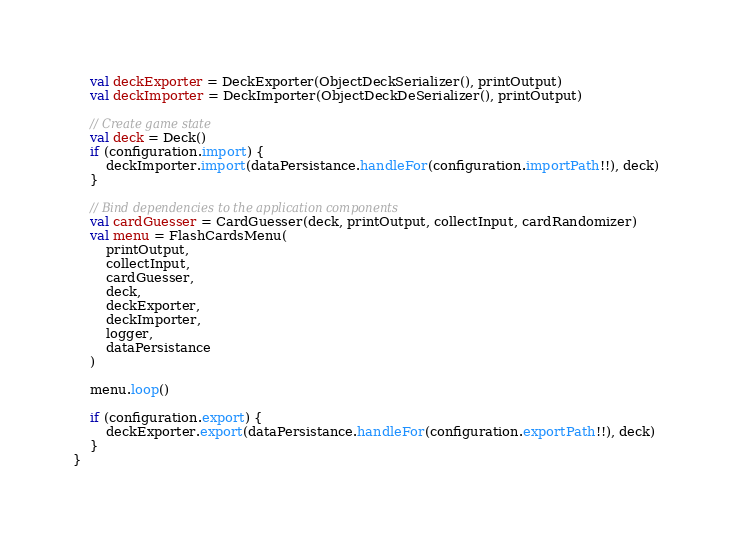Convert code to text. <code><loc_0><loc_0><loc_500><loc_500><_Kotlin_>    val deckExporter = DeckExporter(ObjectDeckSerializer(), printOutput)
    val deckImporter = DeckImporter(ObjectDeckDeSerializer(), printOutput)

    // Create game state
    val deck = Deck()
    if (configuration.import) {
        deckImporter.import(dataPersistance.handleFor(configuration.importPath!!), deck)
    }

    // Bind dependencies to the application components
    val cardGuesser = CardGuesser(deck, printOutput, collectInput, cardRandomizer)
    val menu = FlashCardsMenu(
        printOutput,
        collectInput,
        cardGuesser,
        deck,
        deckExporter,
        deckImporter,
        logger,
        dataPersistance
    )

    menu.loop()

    if (configuration.export) {
        deckExporter.export(dataPersistance.handleFor(configuration.exportPath!!), deck)
    }
}</code> 